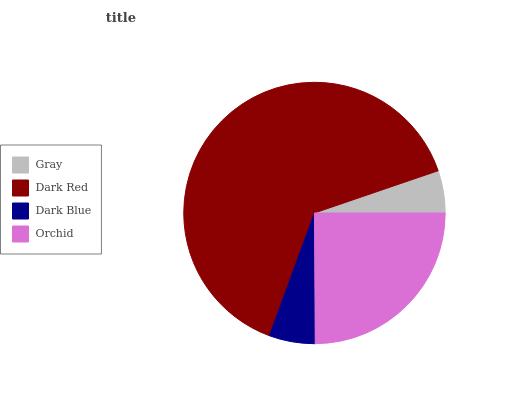Is Gray the minimum?
Answer yes or no. Yes. Is Dark Red the maximum?
Answer yes or no. Yes. Is Dark Blue the minimum?
Answer yes or no. No. Is Dark Blue the maximum?
Answer yes or no. No. Is Dark Red greater than Dark Blue?
Answer yes or no. Yes. Is Dark Blue less than Dark Red?
Answer yes or no. Yes. Is Dark Blue greater than Dark Red?
Answer yes or no. No. Is Dark Red less than Dark Blue?
Answer yes or no. No. Is Orchid the high median?
Answer yes or no. Yes. Is Dark Blue the low median?
Answer yes or no. Yes. Is Dark Red the high median?
Answer yes or no. No. Is Gray the low median?
Answer yes or no. No. 